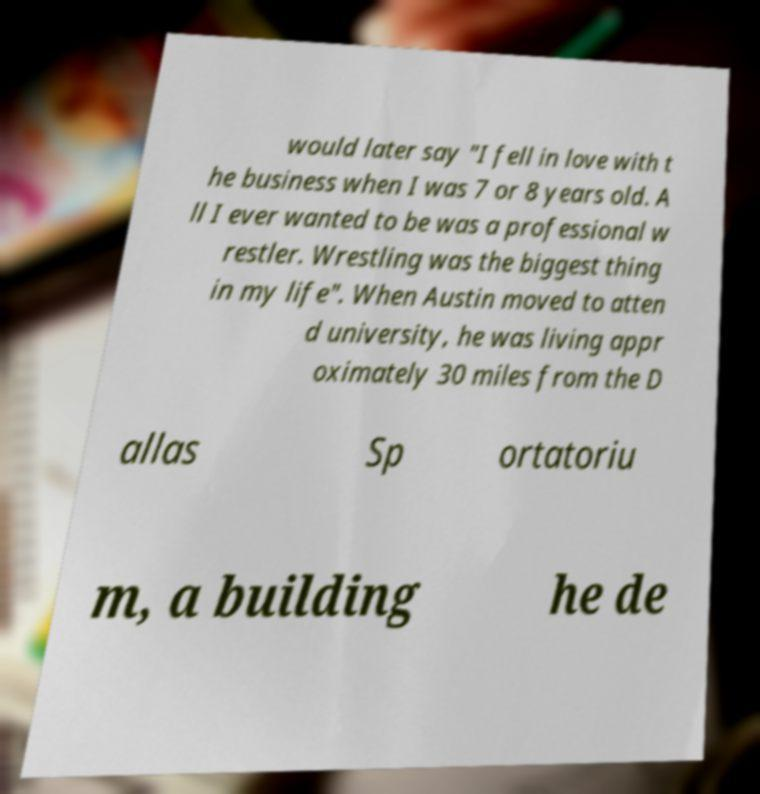Can you read and provide the text displayed in the image?This photo seems to have some interesting text. Can you extract and type it out for me? would later say "I fell in love with t he business when I was 7 or 8 years old. A ll I ever wanted to be was a professional w restler. Wrestling was the biggest thing in my life". When Austin moved to atten d university, he was living appr oximately 30 miles from the D allas Sp ortatoriu m, a building he de 